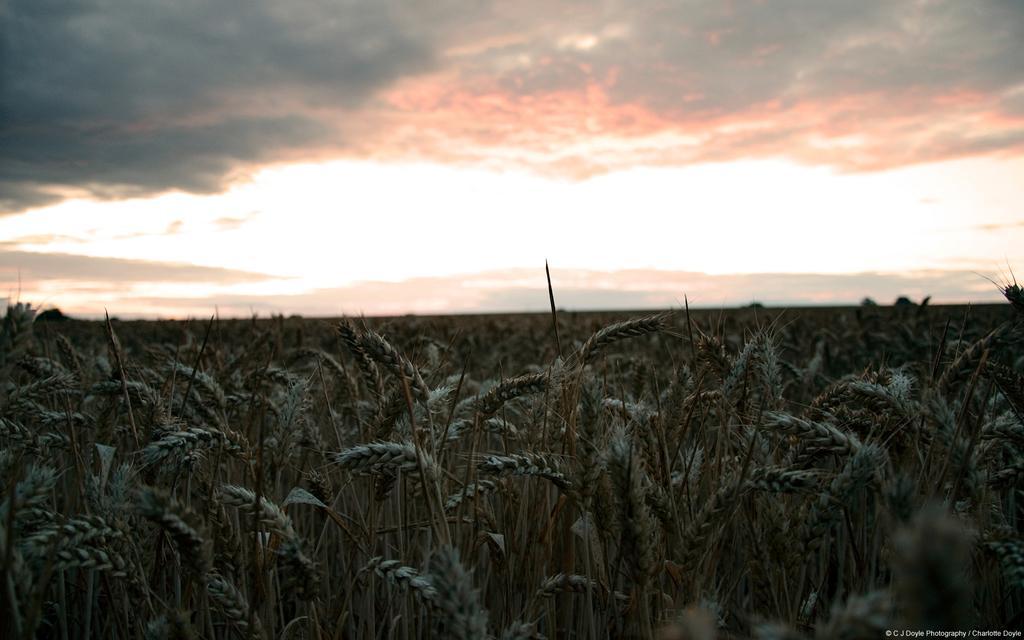In one or two sentences, can you explain what this image depicts? In this image I can see many plants. In the background I can see the clouds and the sky. 